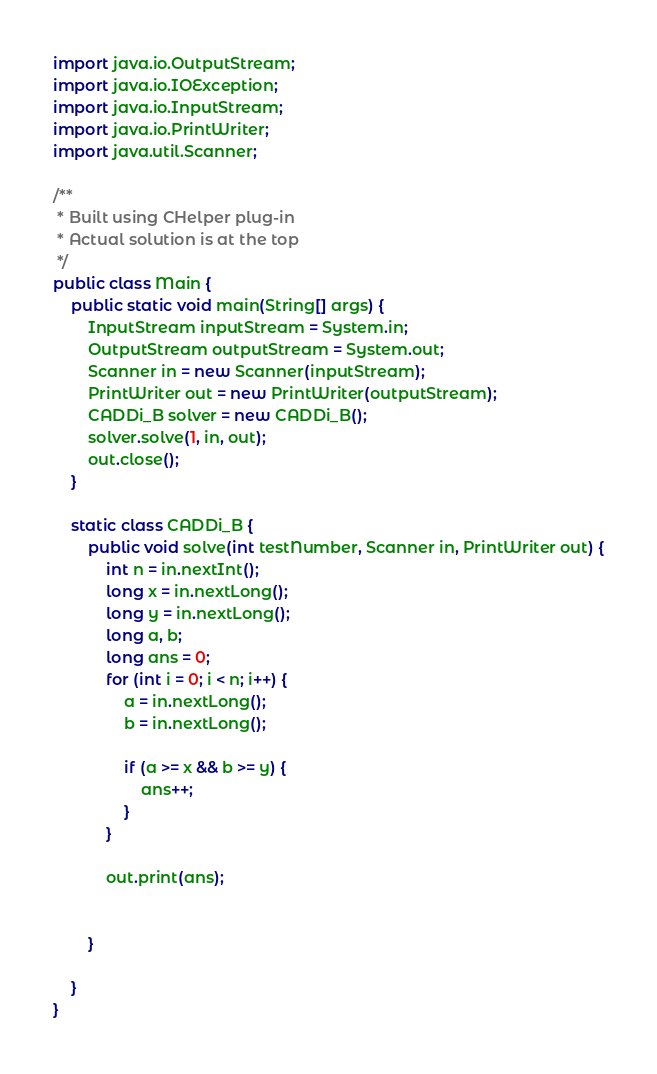Convert code to text. <code><loc_0><loc_0><loc_500><loc_500><_Java_>import java.io.OutputStream;
import java.io.IOException;
import java.io.InputStream;
import java.io.PrintWriter;
import java.util.Scanner;

/**
 * Built using CHelper plug-in
 * Actual solution is at the top
 */
public class Main {
    public static void main(String[] args) {
        InputStream inputStream = System.in;
        OutputStream outputStream = System.out;
        Scanner in = new Scanner(inputStream);
        PrintWriter out = new PrintWriter(outputStream);
        CADDi_B solver = new CADDi_B();
        solver.solve(1, in, out);
        out.close();
    }

    static class CADDi_B {
        public void solve(int testNumber, Scanner in, PrintWriter out) {
            int n = in.nextInt();
            long x = in.nextLong();
            long y = in.nextLong();
            long a, b;
            long ans = 0;
            for (int i = 0; i < n; i++) {
                a = in.nextLong();
                b = in.nextLong();

                if (a >= x && b >= y) {
                    ans++;
                }
            }

            out.print(ans);


        }

    }
}

</code> 